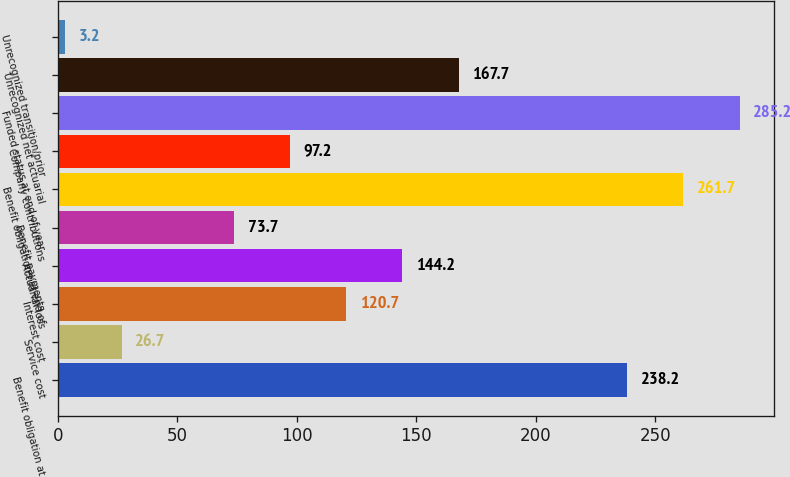Convert chart to OTSL. <chart><loc_0><loc_0><loc_500><loc_500><bar_chart><fcel>Benefit obligation at<fcel>Service cost<fcel>Interest cost<fcel>Actuarial loss<fcel>Benefit payments<fcel>Benefit obligations at end of<fcel>Company contributions<fcel>Funded status at end of year<fcel>Unrecognized net actuarial<fcel>Unrecognized transition/prior<nl><fcel>238.2<fcel>26.7<fcel>120.7<fcel>144.2<fcel>73.7<fcel>261.7<fcel>97.2<fcel>285.2<fcel>167.7<fcel>3.2<nl></chart> 